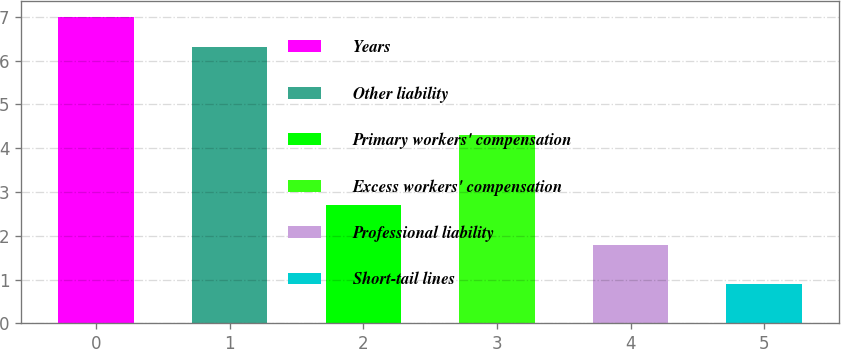Convert chart. <chart><loc_0><loc_0><loc_500><loc_500><bar_chart><fcel>Years<fcel>Other liability<fcel>Primary workers' compensation<fcel>Excess workers' compensation<fcel>Professional liability<fcel>Short-tail lines<nl><fcel>7<fcel>6.3<fcel>2.7<fcel>4.3<fcel>1.8<fcel>0.9<nl></chart> 